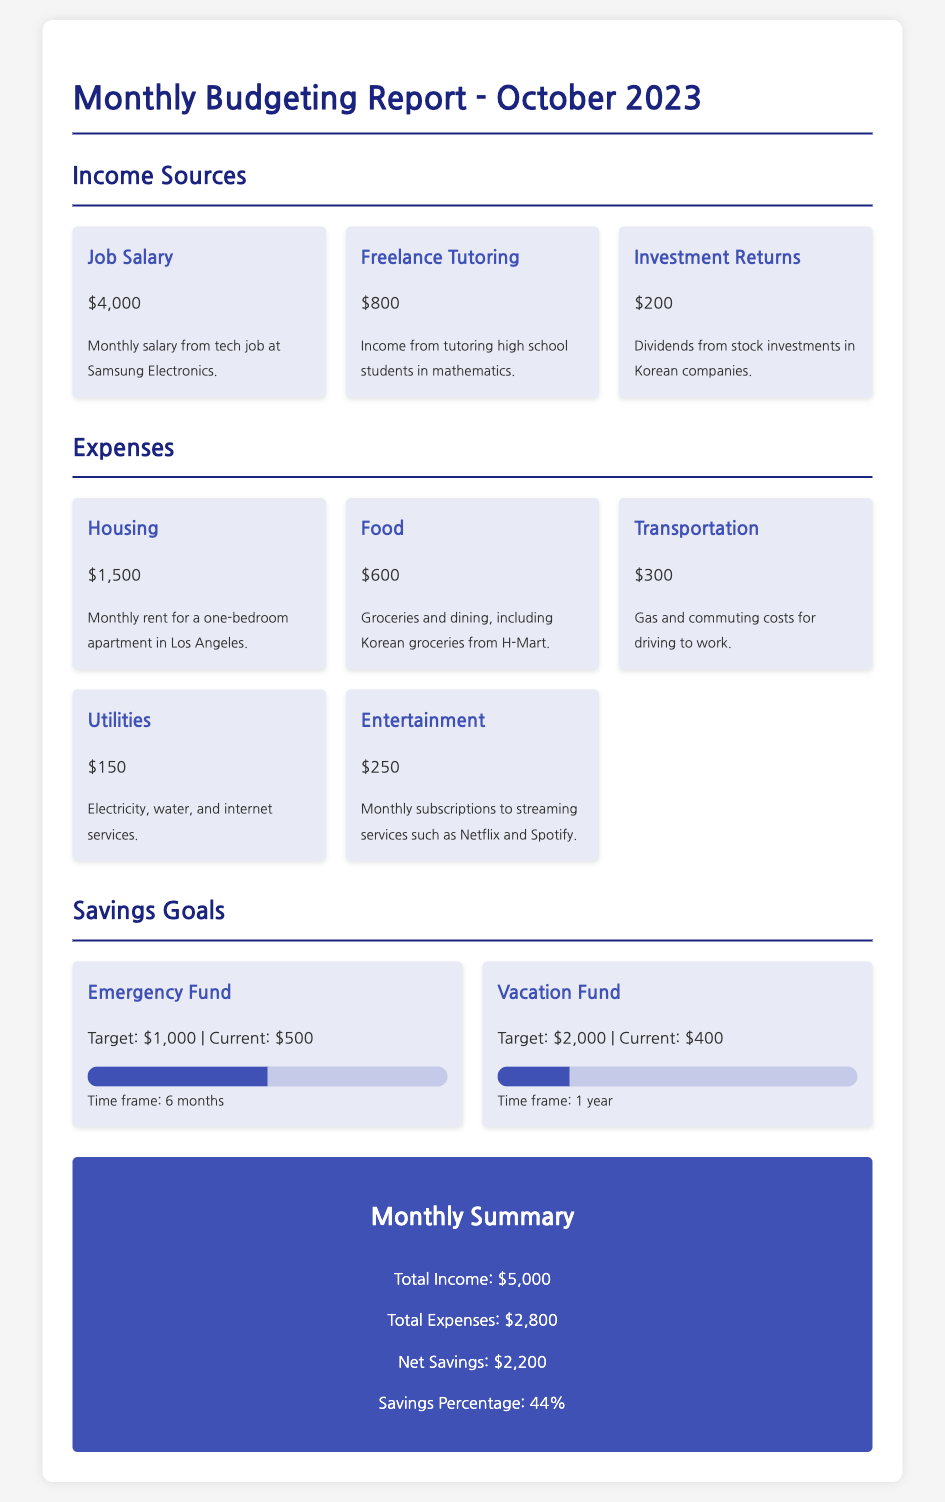What is the total income for October 2023? The total income is the sum of all income sources, which are $4,000, $800, and $200.
Answer: $5,000 What is the current amount in the Emergency Fund? The current amount in the Emergency Fund is stated in the savings goals section of the document.
Answer: $500 How much was spent on food? The food expense is specified in the expenses section of the document.
Answer: $600 What is the target amount for the Vacation Fund? The target amount for the Vacation Fund is listed under the savings goals section.
Answer: $2,000 What is the total expense amount for October 2023? The total expense amount is the addition of all listed expenses, which totals $2,800.
Answer: $2,800 How much net savings are reported for October? The net savings are calculated based on total income minus total expenses, which is $5,000 - $2,800.
Answer: $2,200 What percentage of income is saved this month? The savings percentage is provided in the monthly summary section, calculated from net savings and total income.
Answer: 44% What type of income is mentioned from freelance work? The document specifies the type of income derived from freelance work under income sources.
Answer: Tutoring How long is the time frame to reach the Emergency Fund goal? The time frame for the Emergency Fund is mentioned in the savings goals section.
Answer: 6 months 